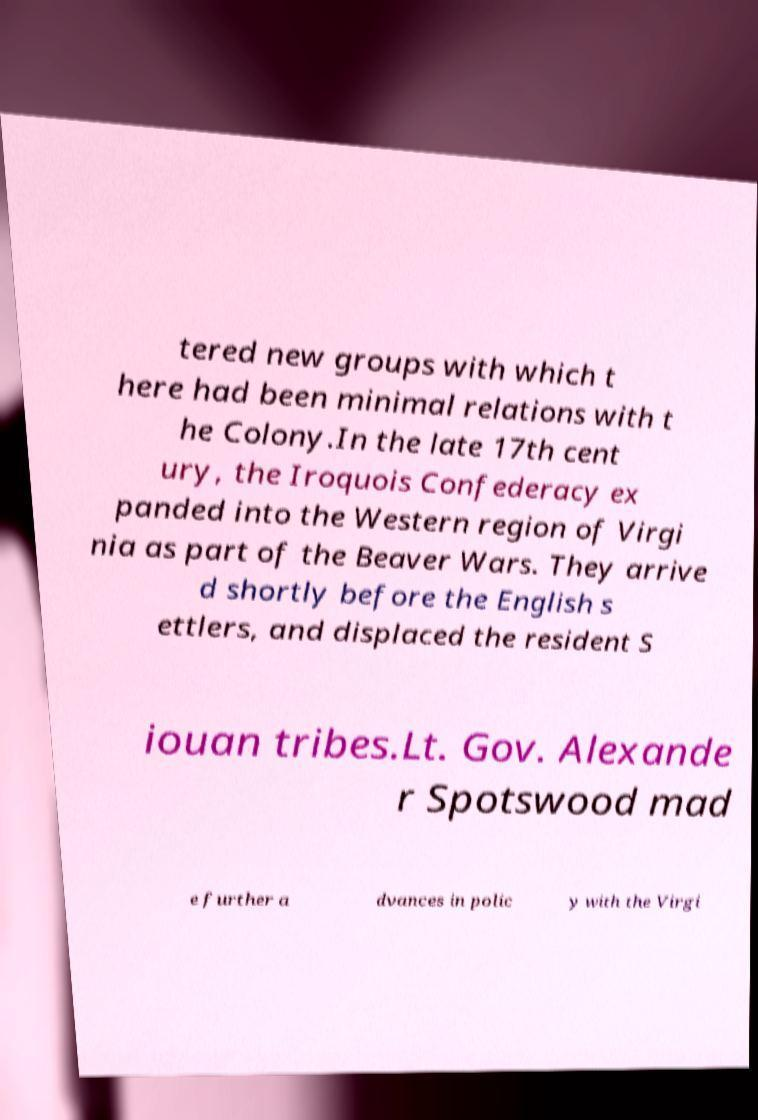Please read and relay the text visible in this image. What does it say? tered new groups with which t here had been minimal relations with t he Colony.In the late 17th cent ury, the Iroquois Confederacy ex panded into the Western region of Virgi nia as part of the Beaver Wars. They arrive d shortly before the English s ettlers, and displaced the resident S iouan tribes.Lt. Gov. Alexande r Spotswood mad e further a dvances in polic y with the Virgi 